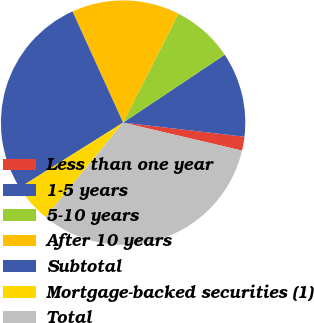<chart> <loc_0><loc_0><loc_500><loc_500><pie_chart><fcel>Less than one year<fcel>1-5 years<fcel>5-10 years<fcel>After 10 years<fcel>Subtotal<fcel>Mortgage-backed securities (1)<fcel>Total<nl><fcel>1.84%<fcel>11.21%<fcel>8.17%<fcel>14.26%<fcel>27.13%<fcel>5.13%<fcel>32.26%<nl></chart> 